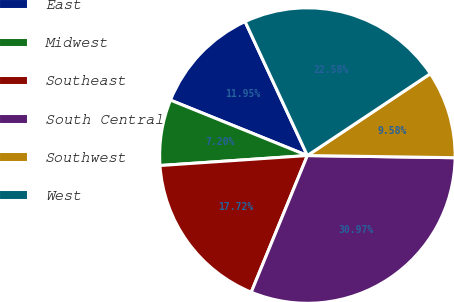Convert chart to OTSL. <chart><loc_0><loc_0><loc_500><loc_500><pie_chart><fcel>East<fcel>Midwest<fcel>Southeast<fcel>South Central<fcel>Southwest<fcel>West<nl><fcel>11.95%<fcel>7.2%<fcel>17.72%<fcel>30.97%<fcel>9.58%<fcel>22.58%<nl></chart> 